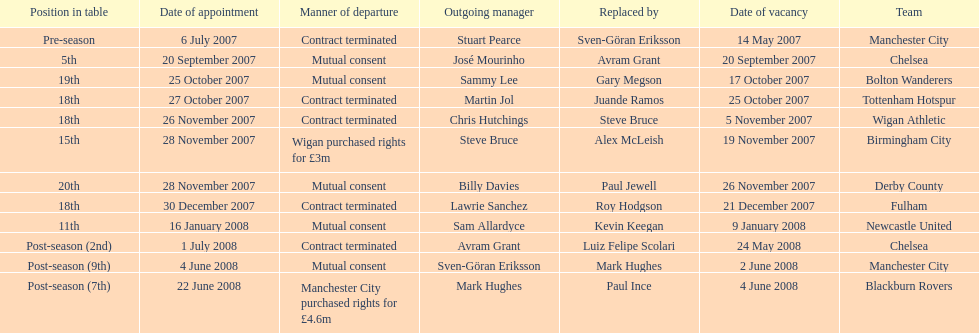What team is listed after manchester city? Chelsea. 